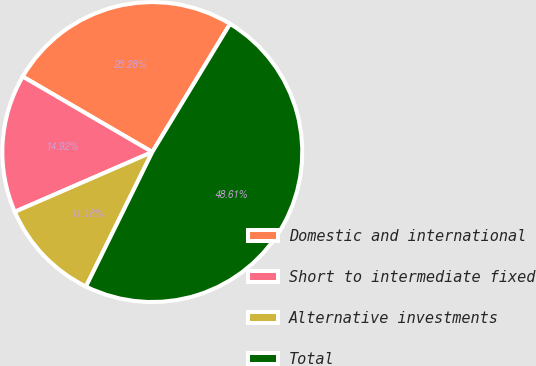Convert chart to OTSL. <chart><loc_0><loc_0><loc_500><loc_500><pie_chart><fcel>Domestic and international<fcel>Short to intermediate fixed<fcel>Alternative investments<fcel>Total<nl><fcel>25.28%<fcel>14.92%<fcel>11.18%<fcel>48.61%<nl></chart> 